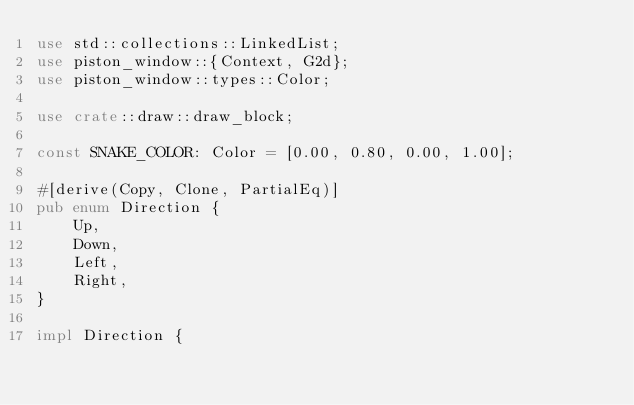Convert code to text. <code><loc_0><loc_0><loc_500><loc_500><_Rust_>use std::collections::LinkedList;
use piston_window::{Context, G2d};
use piston_window::types::Color;

use crate::draw::draw_block;

const SNAKE_COLOR: Color = [0.00, 0.80, 0.00, 1.00];

#[derive(Copy, Clone, PartialEq)]
pub enum Direction {
    Up,
    Down,
    Left,
    Right,
}

impl Direction {</code> 